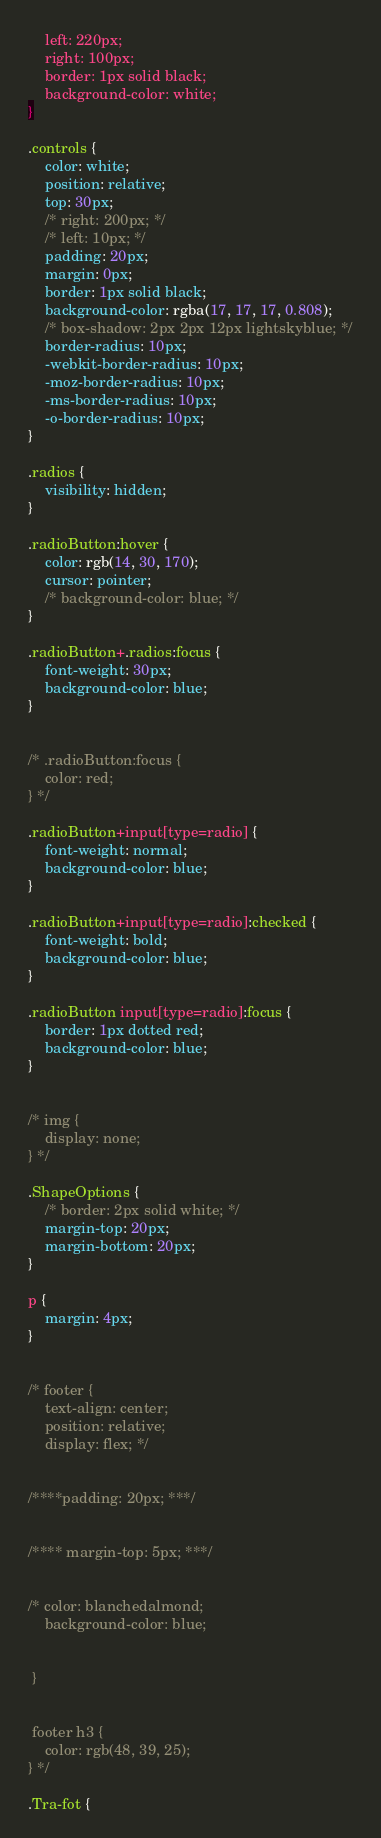<code> <loc_0><loc_0><loc_500><loc_500><_CSS_>    left: 220px;
    right: 100px;
    border: 1px solid black;
    background-color: white;
}

.controls {
    color: white;
    position: relative;
    top: 30px;
    /* right: 200px; */
    /* left: 10px; */
    padding: 20px;
    margin: 0px;
    border: 1px solid black;
    background-color: rgba(17, 17, 17, 0.808);
    /* box-shadow: 2px 2px 12px lightskyblue; */
    border-radius: 10px;
    -webkit-border-radius: 10px;
    -moz-border-radius: 10px;
    -ms-border-radius: 10px;
    -o-border-radius: 10px;
}

.radios {
    visibility: hidden;
}

.radioButton:hover {
    color: rgb(14, 30, 170);
    cursor: pointer;
    /* background-color: blue; */
}

.radioButton+.radios:focus {
    font-weight: 30px;
    background-color: blue;
}


/* .radioButton:focus {
    color: red;
} */

.radioButton+input[type=radio] {
    font-weight: normal;
    background-color: blue;
}

.radioButton+input[type=radio]:checked {
    font-weight: bold;
    background-color: blue;
}

.radioButton input[type=radio]:focus {
    border: 1px dotted red;
    background-color: blue;
}


/* img {
    display: none;
} */

.ShapeOptions {
    /* border: 2px solid white; */
    margin-top: 20px;
    margin-bottom: 20px;
}

p {
    margin: 4px;
}


/* footer {
    text-align: center;
    position: relative;
    display: flex; */


/****padding: 20px; ***/


/**** margin-top: 5px; ***/


/* color: blanchedalmond;
    background-color: blue;


 } 


 footer h3 {
    color: rgb(48, 39, 25);
} */

.Tra-fot {</code> 